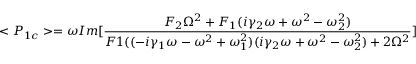<formula> <loc_0><loc_0><loc_500><loc_500>< P _ { 1 c } > = \omega I m [ \frac { F _ { 2 } \Omega ^ { 2 } + F _ { 1 } ( i \gamma _ { 2 } \omega + \omega ^ { 2 } - \omega _ { 2 } ^ { 2 } ) } { F 1 ( ( - i \gamma _ { 1 } \omega - \omega ^ { 2 } + \omega _ { 1 } ^ { 2 } ) ( i \gamma _ { 2 } \omega + \omega ^ { 2 } - \omega _ { 2 } ^ { 2 } ) + 2 \Omega ^ { 2 } } ]</formula> 